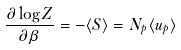Convert formula to latex. <formula><loc_0><loc_0><loc_500><loc_500>\frac { \partial \log Z } { \partial \beta } = - \langle S \rangle = N _ { p } \langle u _ { p } \rangle</formula> 